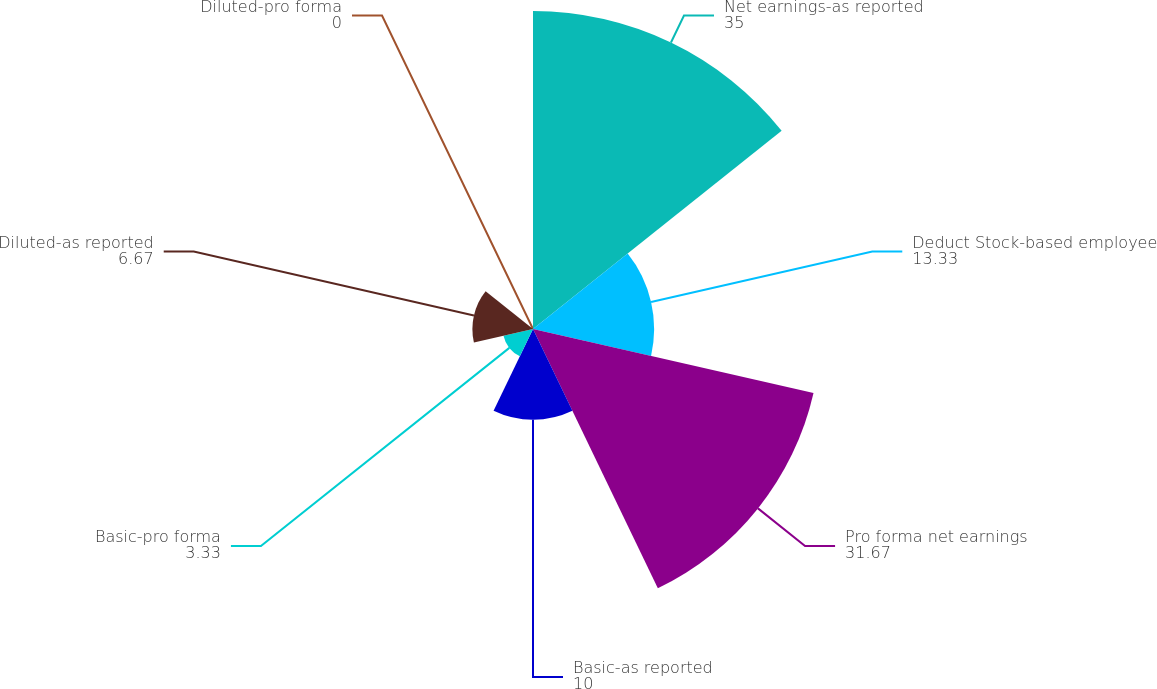<chart> <loc_0><loc_0><loc_500><loc_500><pie_chart><fcel>Net earnings-as reported<fcel>Deduct Stock-based employee<fcel>Pro forma net earnings<fcel>Basic-as reported<fcel>Basic-pro forma<fcel>Diluted-as reported<fcel>Diluted-pro forma<nl><fcel>35.0%<fcel>13.33%<fcel>31.67%<fcel>10.0%<fcel>3.33%<fcel>6.67%<fcel>0.0%<nl></chart> 